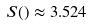Convert formula to latex. <formula><loc_0><loc_0><loc_500><loc_500>S ( ) \approx 3 . 5 2 4</formula> 